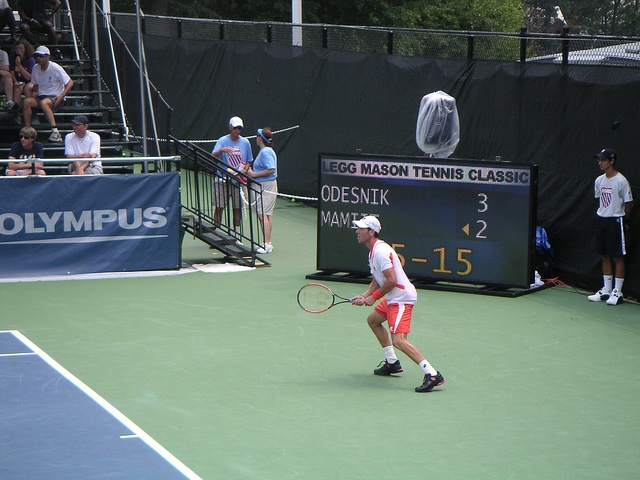Describe the objects in this image and their specific colors. I can see people in darkgray, lavender, brown, and gray tones, people in darkgray, black, and gray tones, people in darkgray, black, and gray tones, people in darkgray, black, and gray tones, and people in darkgray, gray, black, and lightgray tones in this image. 